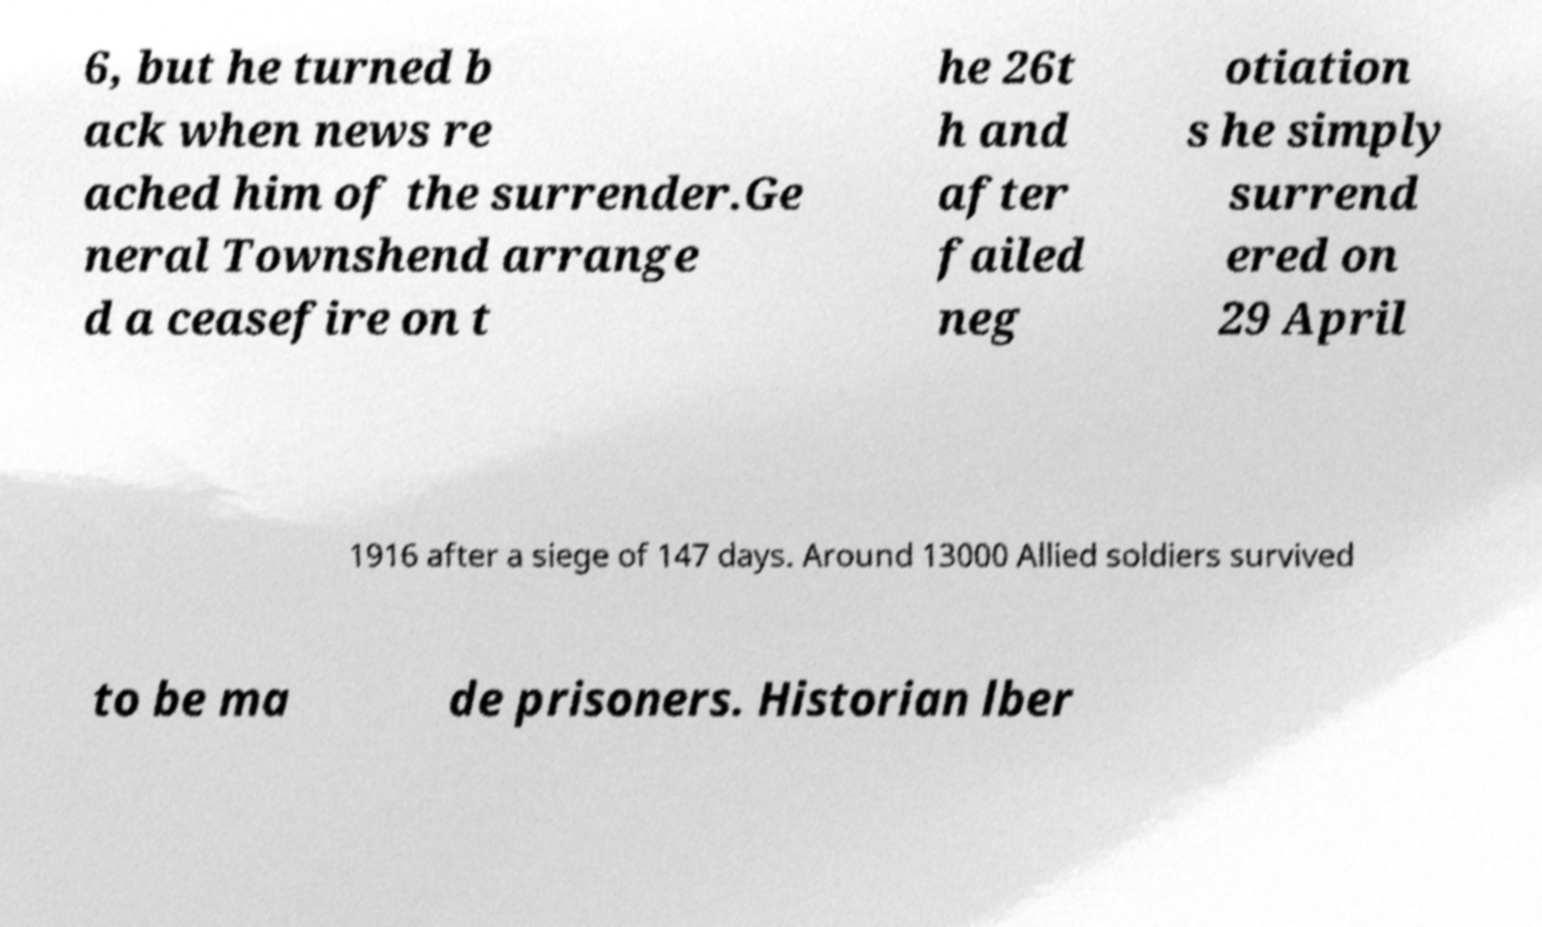Could you assist in decoding the text presented in this image and type it out clearly? 6, but he turned b ack when news re ached him of the surrender.Ge neral Townshend arrange d a ceasefire on t he 26t h and after failed neg otiation s he simply surrend ered on 29 April 1916 after a siege of 147 days. Around 13000 Allied soldiers survived to be ma de prisoners. Historian lber 